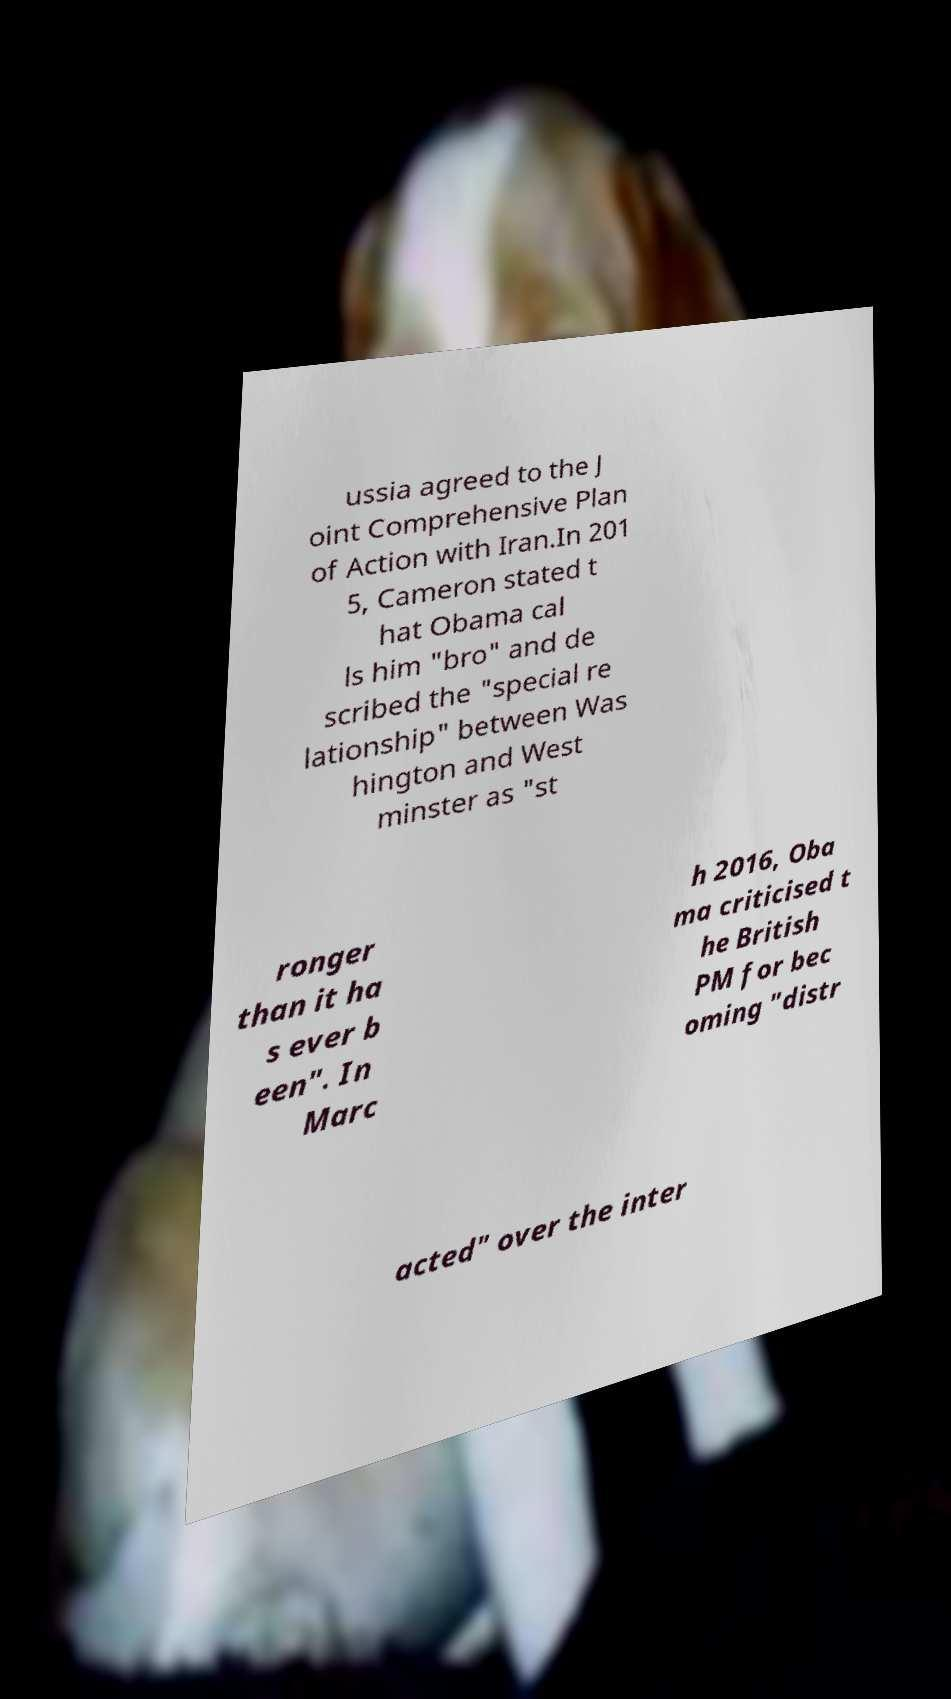There's text embedded in this image that I need extracted. Can you transcribe it verbatim? ussia agreed to the J oint Comprehensive Plan of Action with Iran.In 201 5, Cameron stated t hat Obama cal ls him "bro" and de scribed the "special re lationship" between Was hington and West minster as "st ronger than it ha s ever b een". In Marc h 2016, Oba ma criticised t he British PM for bec oming "distr acted" over the inter 